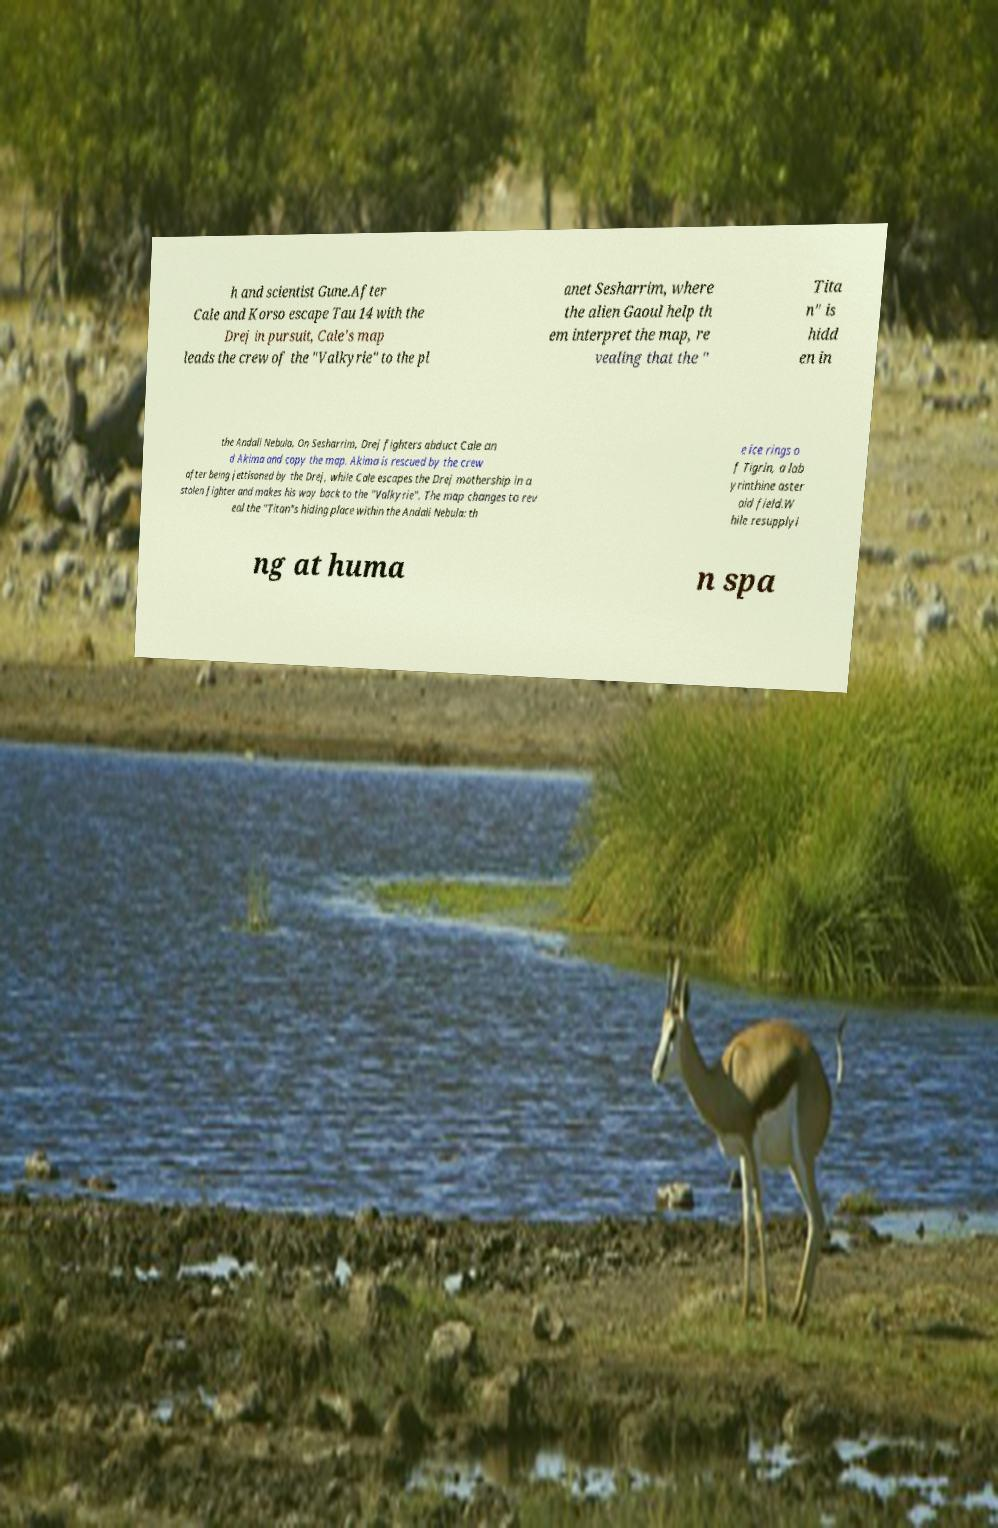Can you read and provide the text displayed in the image?This photo seems to have some interesting text. Can you extract and type it out for me? h and scientist Gune.After Cale and Korso escape Tau 14 with the Drej in pursuit, Cale's map leads the crew of the "Valkyrie" to the pl anet Sesharrim, where the alien Gaoul help th em interpret the map, re vealing that the " Tita n" is hidd en in the Andali Nebula. On Sesharrim, Drej fighters abduct Cale an d Akima and copy the map. Akima is rescued by the crew after being jettisoned by the Drej, while Cale escapes the Drej mothership in a stolen fighter and makes his way back to the "Valkyrie". The map changes to rev eal the "Titan"s hiding place within the Andali Nebula: th e ice rings o f Tigrin, a lab yrinthine aster oid field.W hile resupplyi ng at huma n spa 